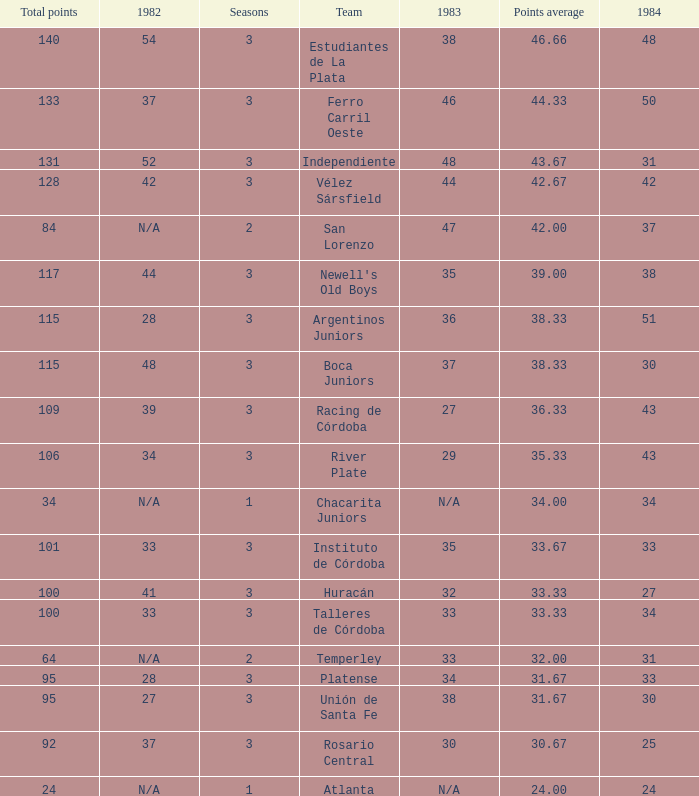What is the total for 1984 for the team with 100 points total and more than 3 seasons? None. 